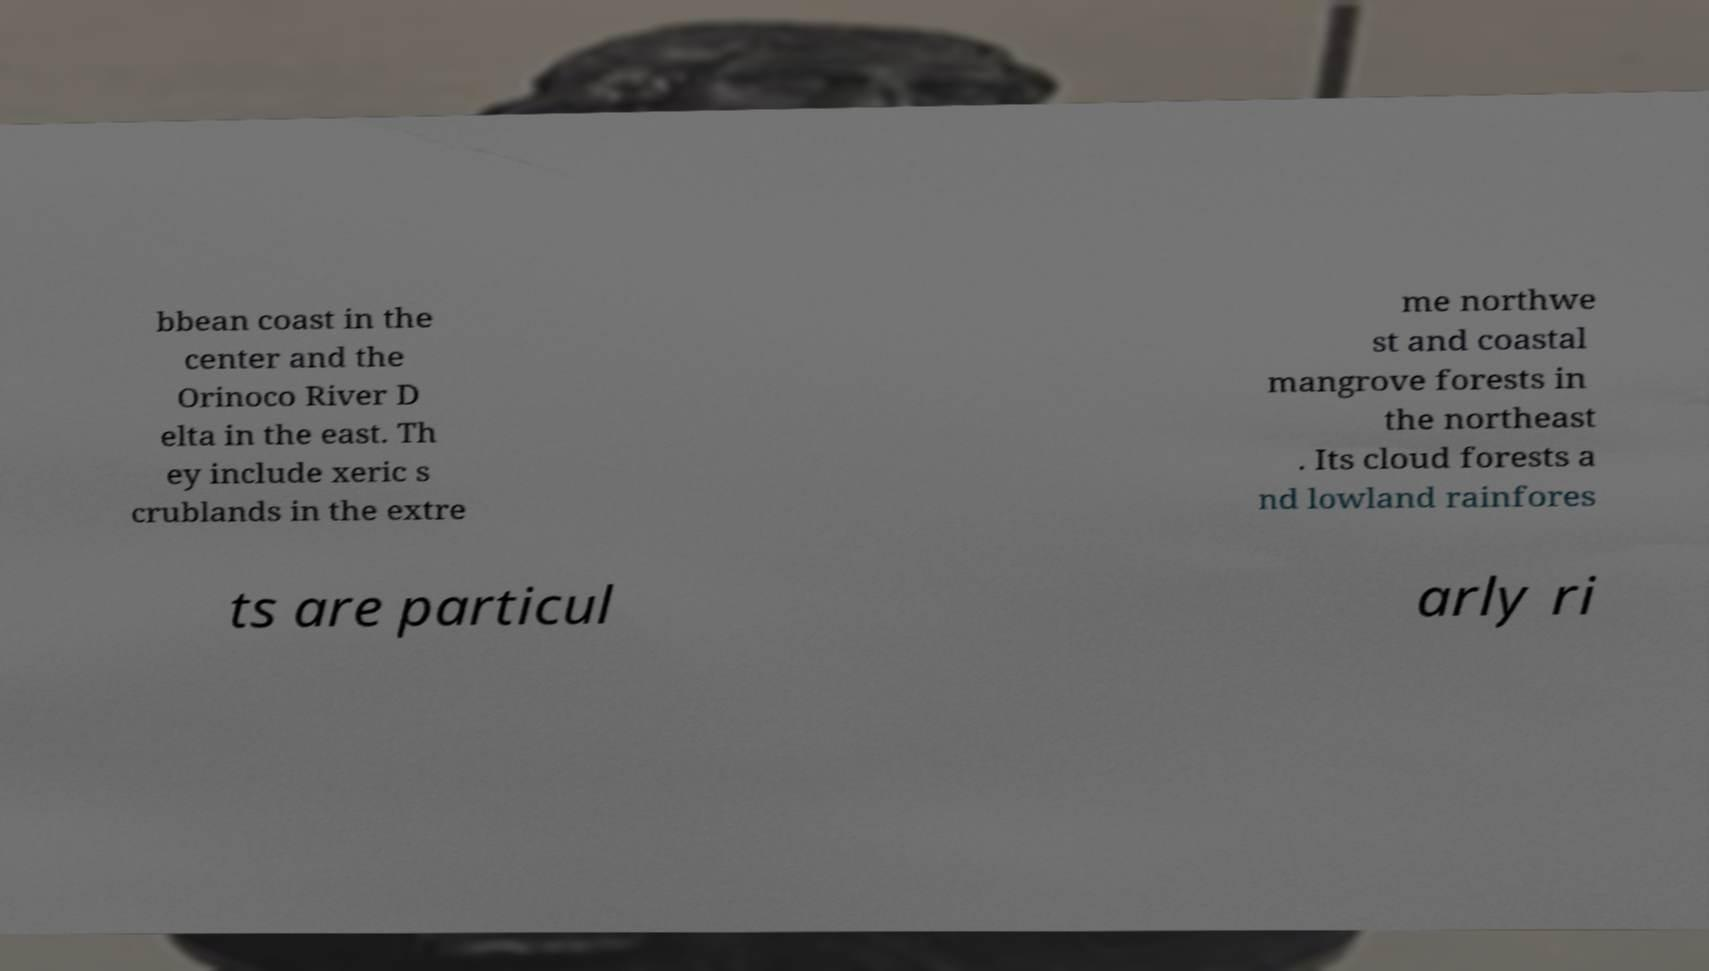Can you accurately transcribe the text from the provided image for me? bbean coast in the center and the Orinoco River D elta in the east. Th ey include xeric s crublands in the extre me northwe st and coastal mangrove forests in the northeast . Its cloud forests a nd lowland rainfores ts are particul arly ri 